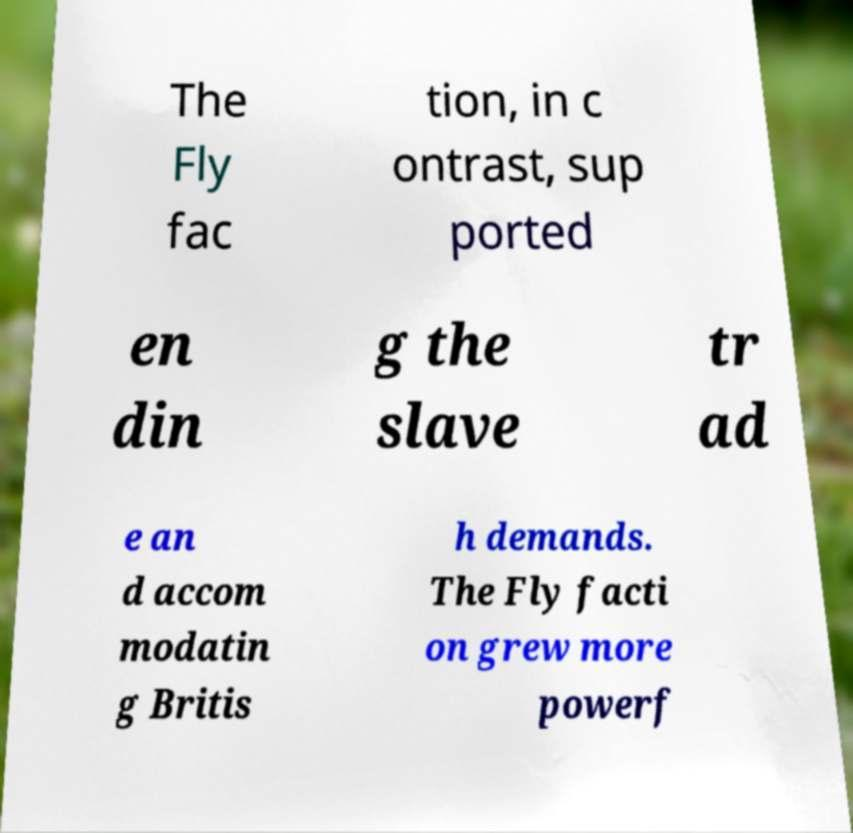Could you extract and type out the text from this image? The Fly fac tion, in c ontrast, sup ported en din g the slave tr ad e an d accom modatin g Britis h demands. The Fly facti on grew more powerf 